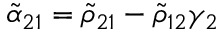Convert formula to latex. <formula><loc_0><loc_0><loc_500><loc_500>\tilde { \alpha } _ { 2 1 } = \tilde { \rho } _ { 2 1 } - \tilde { \rho } _ { 1 2 } \gamma _ { 2 }</formula> 